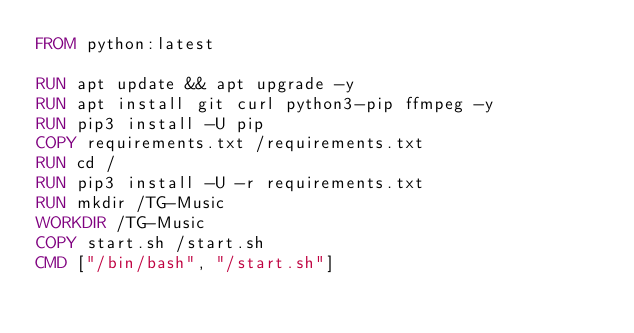Convert code to text. <code><loc_0><loc_0><loc_500><loc_500><_Dockerfile_>FROM python:latest

RUN apt update && apt upgrade -y
RUN apt install git curl python3-pip ffmpeg -y
RUN pip3 install -U pip
COPY requirements.txt /requirements.txt
RUN cd /
RUN pip3 install -U -r requirements.txt
RUN mkdir /TG-Music
WORKDIR /TG-Music
COPY start.sh /start.sh
CMD ["/bin/bash", "/start.sh"]
</code> 